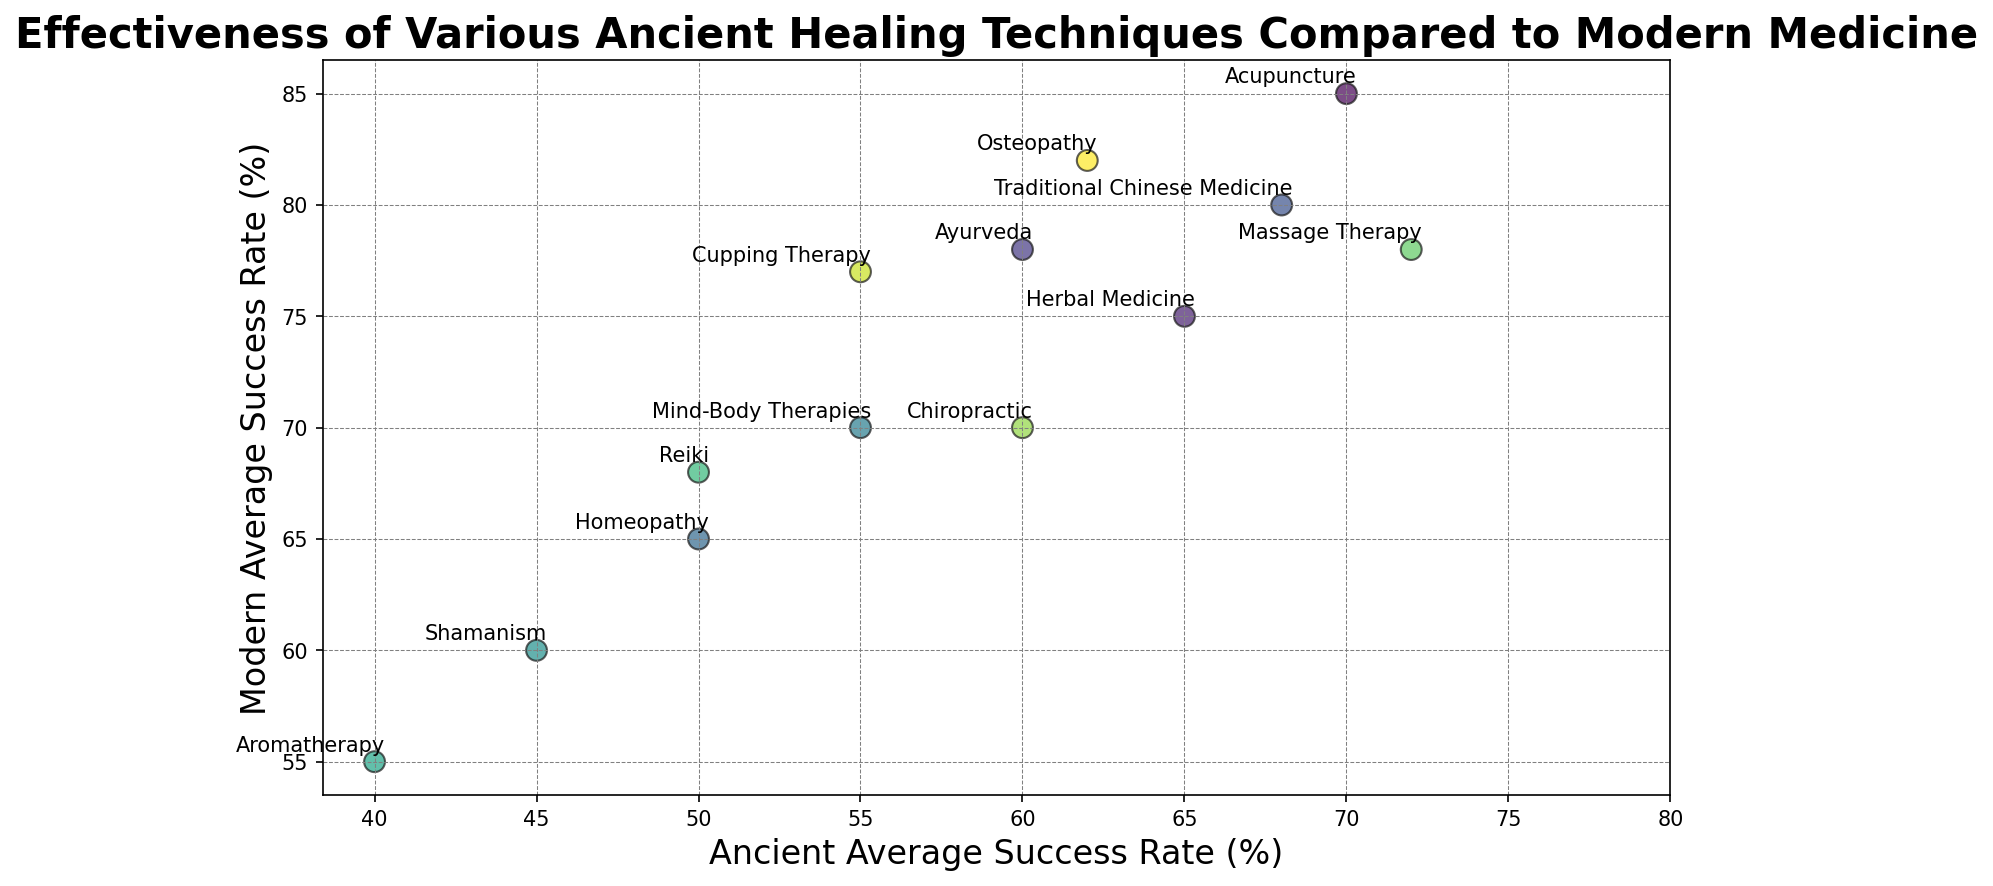What's the difference in the average success rates between Acupuncture and Herbal Medicine for modern techniques? The modern average success rate for Acupuncture is 85%, and for Herbal Medicine, it is 75%. Subtracting 75 from 85 gives the difference.
Answer: 10% Which technique has the lowest ancient average success rate, and what is the value? The technique with the lowest ancient average success rate is identified by looking at the lowest value on the x-axis, which is Shamanism with a value of 45%.
Answer: Shamanism, 45% How many techniques have a higher modern average success rate compared to their ancient average success rate? Count the techniques where the modern average success rate (y-axis) is higher than the ancient average success rate (x-axis). All techniques shown meet this criterion.
Answer: 13 Which technique shows the smallest difference between ancient and modern average success rates, and what is the value? Calculate the differences for each: Acupuncture (15), Herbal Medicine (10), Ayurveda (18), Traditional Chinese Medicine (12), Homeopathy (15), Mind-Body Therapies (15), Shamanism (15), Aromatherapy (15), Reiki (18), Massage Therapy (6), Chiropractic (10), Cupping Therapy (22), Osteopathy (20). The smallest difference is for Massage Therapy, which is 6%.
Answer: Massage Therapy, 6% Are there any techniques with the same modern average success rate? If so, which ones and what is the rate? Check for duplicate values on the y-axis. Traditional Chinese Medicine and Massage Therapy both have a modern average success rate of 78%.
Answer: Traditional Chinese Medicine and Massage Therapy, 78% Which technique has the highest ancient average success rate, and what is the value? The technique with the highest ancient average success rate is identified by looking at the highest value on the x-axis, which is Massage Therapy with a value of 72%.
Answer: Massage Therapy, 72% What is the average modern success rate of all the techniques represented in the scatter plot? Sum all the modern average success rates and divide by the number of techniques: (85 + 75 + 78 + 80 + 65 + 70 + 60 + 55 + 68 + 78 + 70 + 77 + 82) / 13 = 861 / 13 = 66.23
Answer: 66.23% Which technique has the highest modern average success rate, and what is the value? The technique with the highest modern average success rate is identified by looking at the highest value on the y-axis, which is Acupuncture with a value of 85%.
Answer: Acupuncture, 85% What is the range of ancient average success rates in the scatter plot? Calculate the range by subtracting the lowest ancient average success rate (Shamanism, 45%) from the highest (Massage Therapy, 72%). 72 - 45 = 27
Answer: 27 